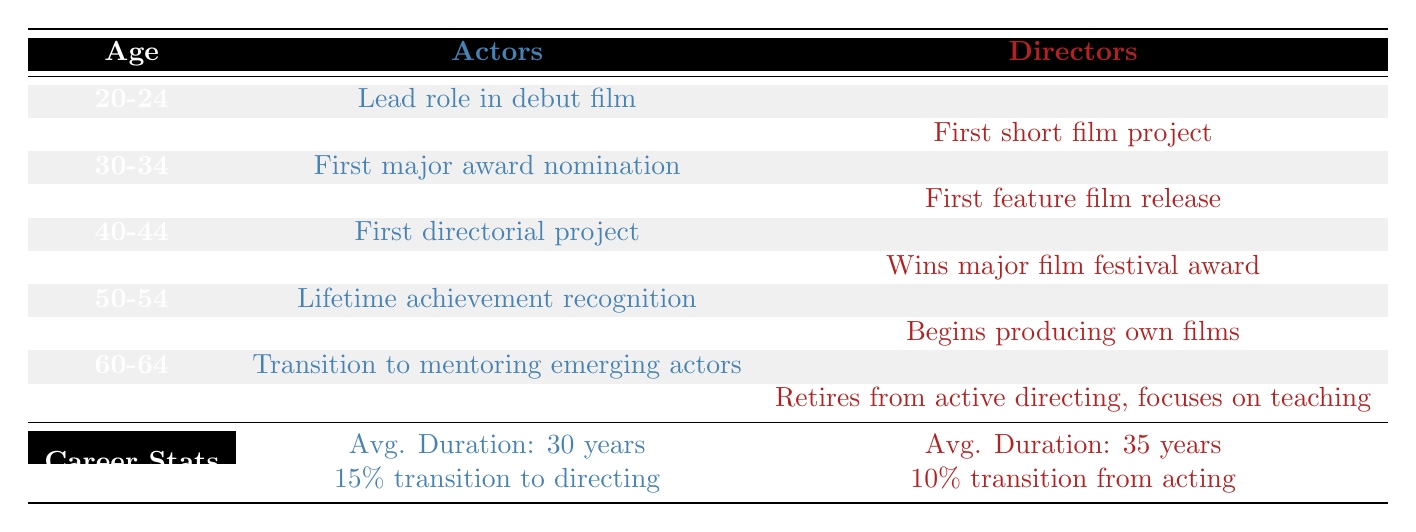What is the average career duration for actors? The table specifies that the average career duration for actors is listed as 30 years.
Answer: 30 years At what age do most actors achieve their first major award nomination? According to the table, actors typically receive their first major award nomination at the age of 30.
Answer: 30 What percentage of actors transition to directing? The table indicates that 15% of actors transition to directing during their careers.
Answer: 15% Do directors transition from acting more than actors transition to directing? The table shows that 10% of directors transition from acting, while 15% of actors transition to directing, which means actors transition to directing more than directors do from acting.
Answer: Yes What is the age difference between when actors receive their first major award nomination and when directors release their first feature film? Actors receive their first major award nomination at age 30, and directors release their first feature film at age 35. The age difference is 35 - 30 = 5 years.
Answer: 5 years What milestones do directors achieve earlier compared to actors? Directors achieve their first short film project at age 25, while actors start with their lead role in a debut film at age 20. Since actors start their milestones earlier, they have the lead role first. Thus, directors achieve milestones slightly later than actors in this case.
Answer: No noticeable earlier milestones How does the average career duration of directors compare to that of actors? The average career duration for directors is 35 years, which is 5 years longer than actors' 30 years. This shows that directors tend to have longer careers compared to actors.
Answer: Directors have a longer average career duration What is the combined total of ages when actors achieve both their first major award nomination and their first directorial project? The first major award nomination occurs at age 30 and the first directorial project occurs at age 40 for actors. Adding these ages together gives us 30 + 40 = 70 years.
Answer: 70 years At what age do actors typically transition to mentoring emerging actors? The table states that actors transition to mentoring emerging actors at the age of 60.
Answer: 60 